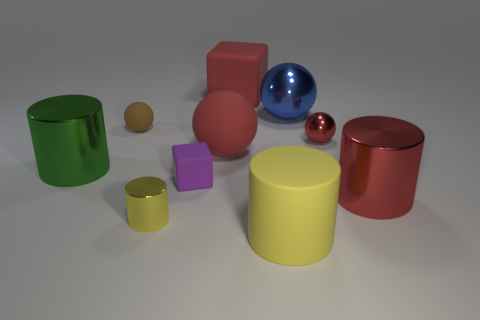Subtract all cylinders. How many objects are left? 6 Subtract 0 purple balls. How many objects are left? 10 Subtract all small red spheres. Subtract all small purple rubber objects. How many objects are left? 8 Add 1 small purple rubber things. How many small purple rubber things are left? 2 Add 5 big red metal cylinders. How many big red metal cylinders exist? 6 